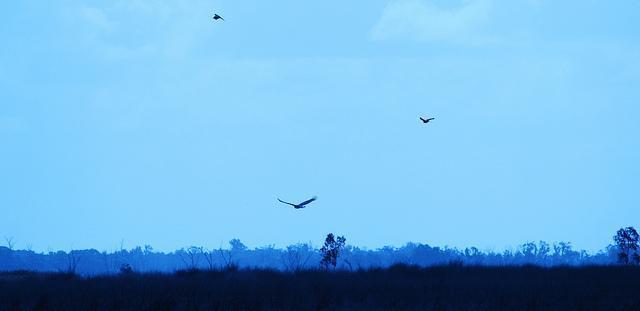How many birds are shown?
Give a very brief answer. 3. 